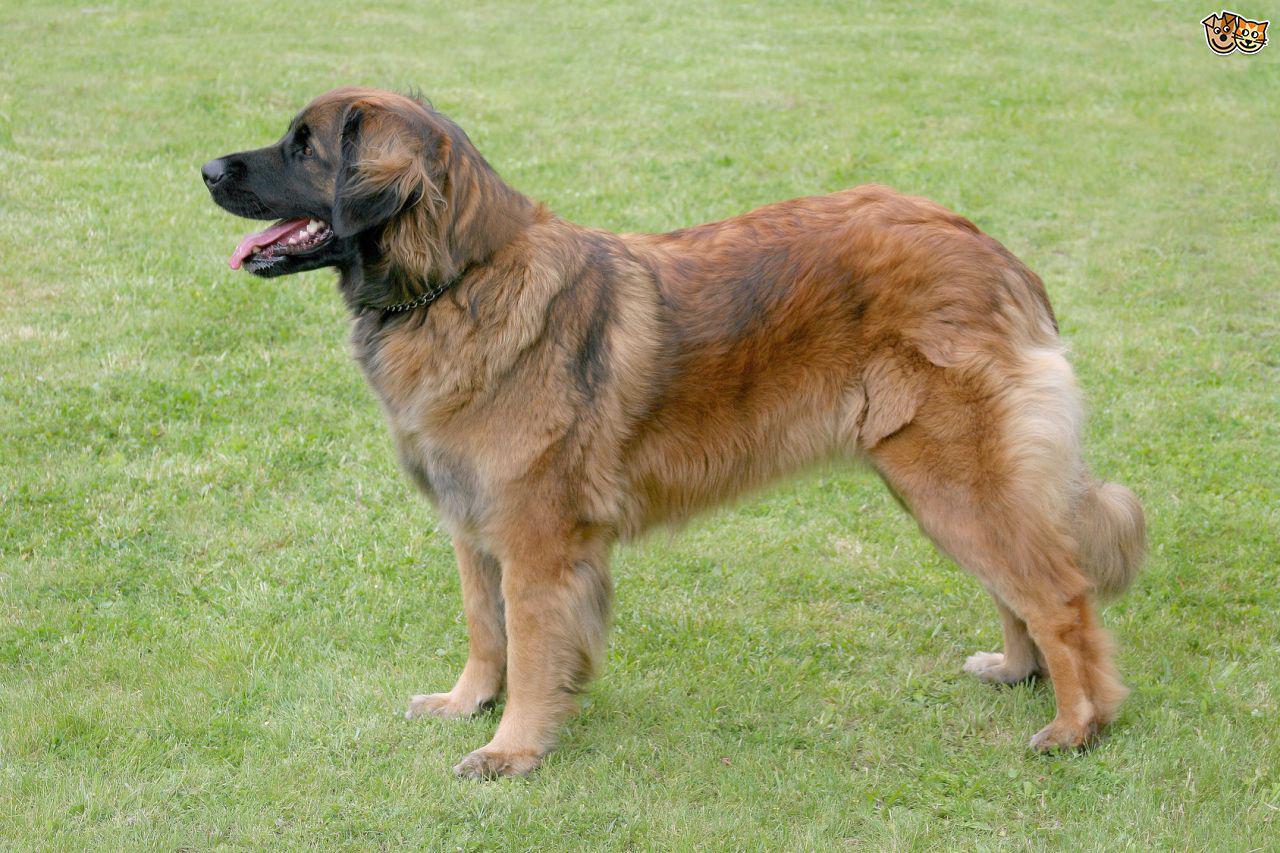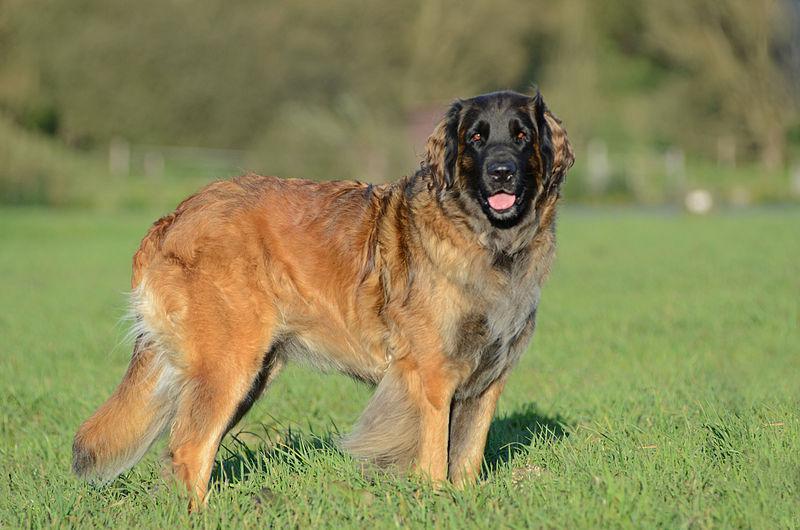The first image is the image on the left, the second image is the image on the right. Given the left and right images, does the statement "One of the dogs has its belly on the ground." hold true? Answer yes or no. No. 